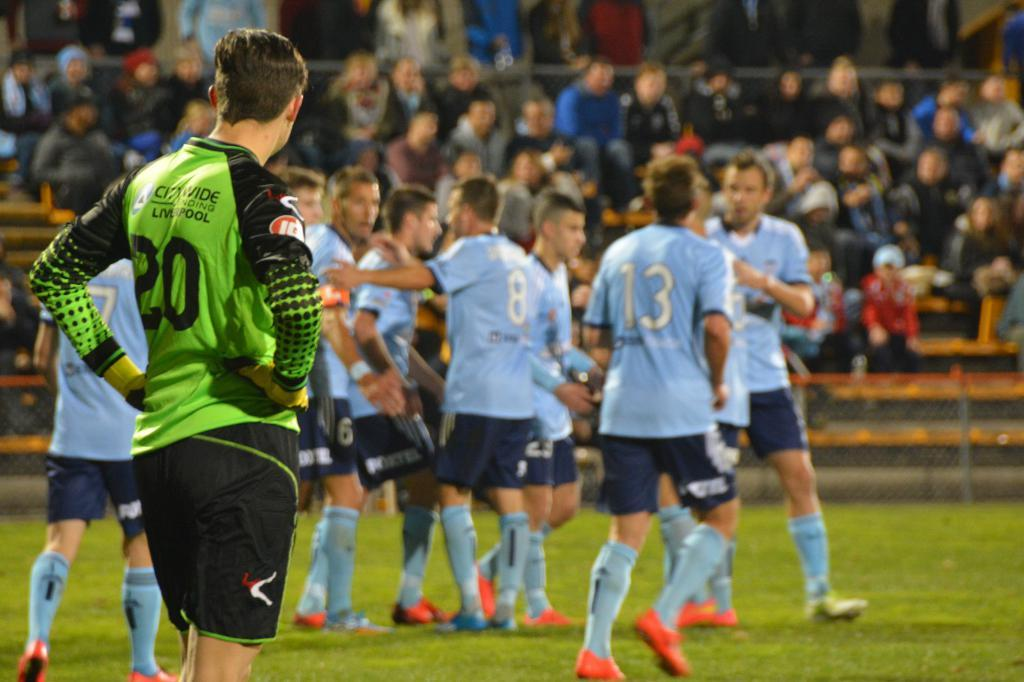<image>
Present a compact description of the photo's key features. Numbers 8, 13, and 20 play a soccer game with teammates. 